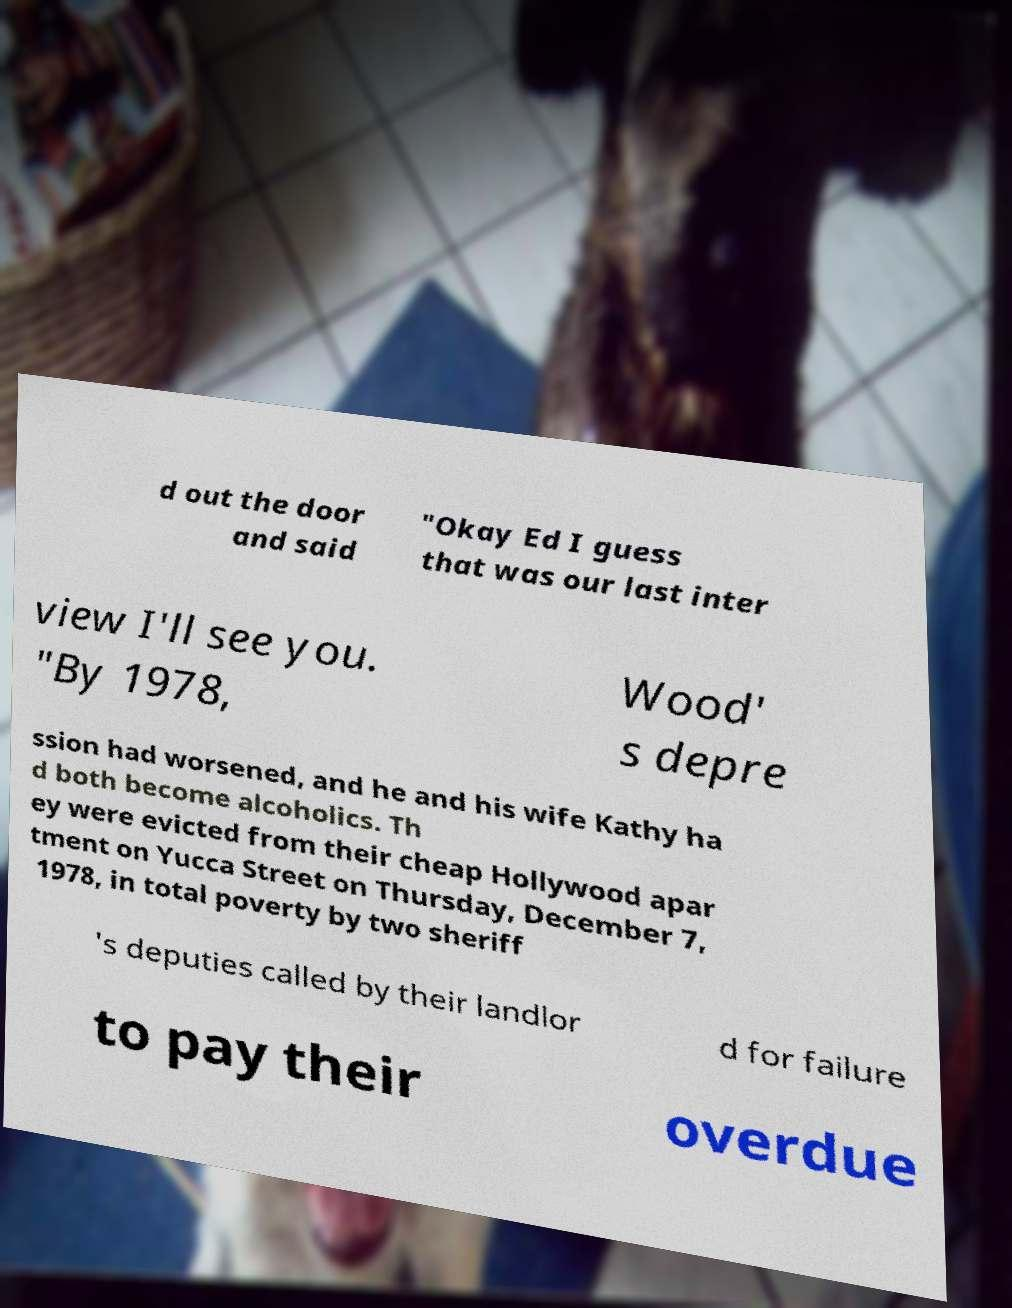I need the written content from this picture converted into text. Can you do that? d out the door and said "Okay Ed I guess that was our last inter view I'll see you. "By 1978, Wood' s depre ssion had worsened, and he and his wife Kathy ha d both become alcoholics. Th ey were evicted from their cheap Hollywood apar tment on Yucca Street on Thursday, December 7, 1978, in total poverty by two sheriff 's deputies called by their landlor d for failure to pay their overdue 